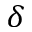<formula> <loc_0><loc_0><loc_500><loc_500>\delta</formula> 